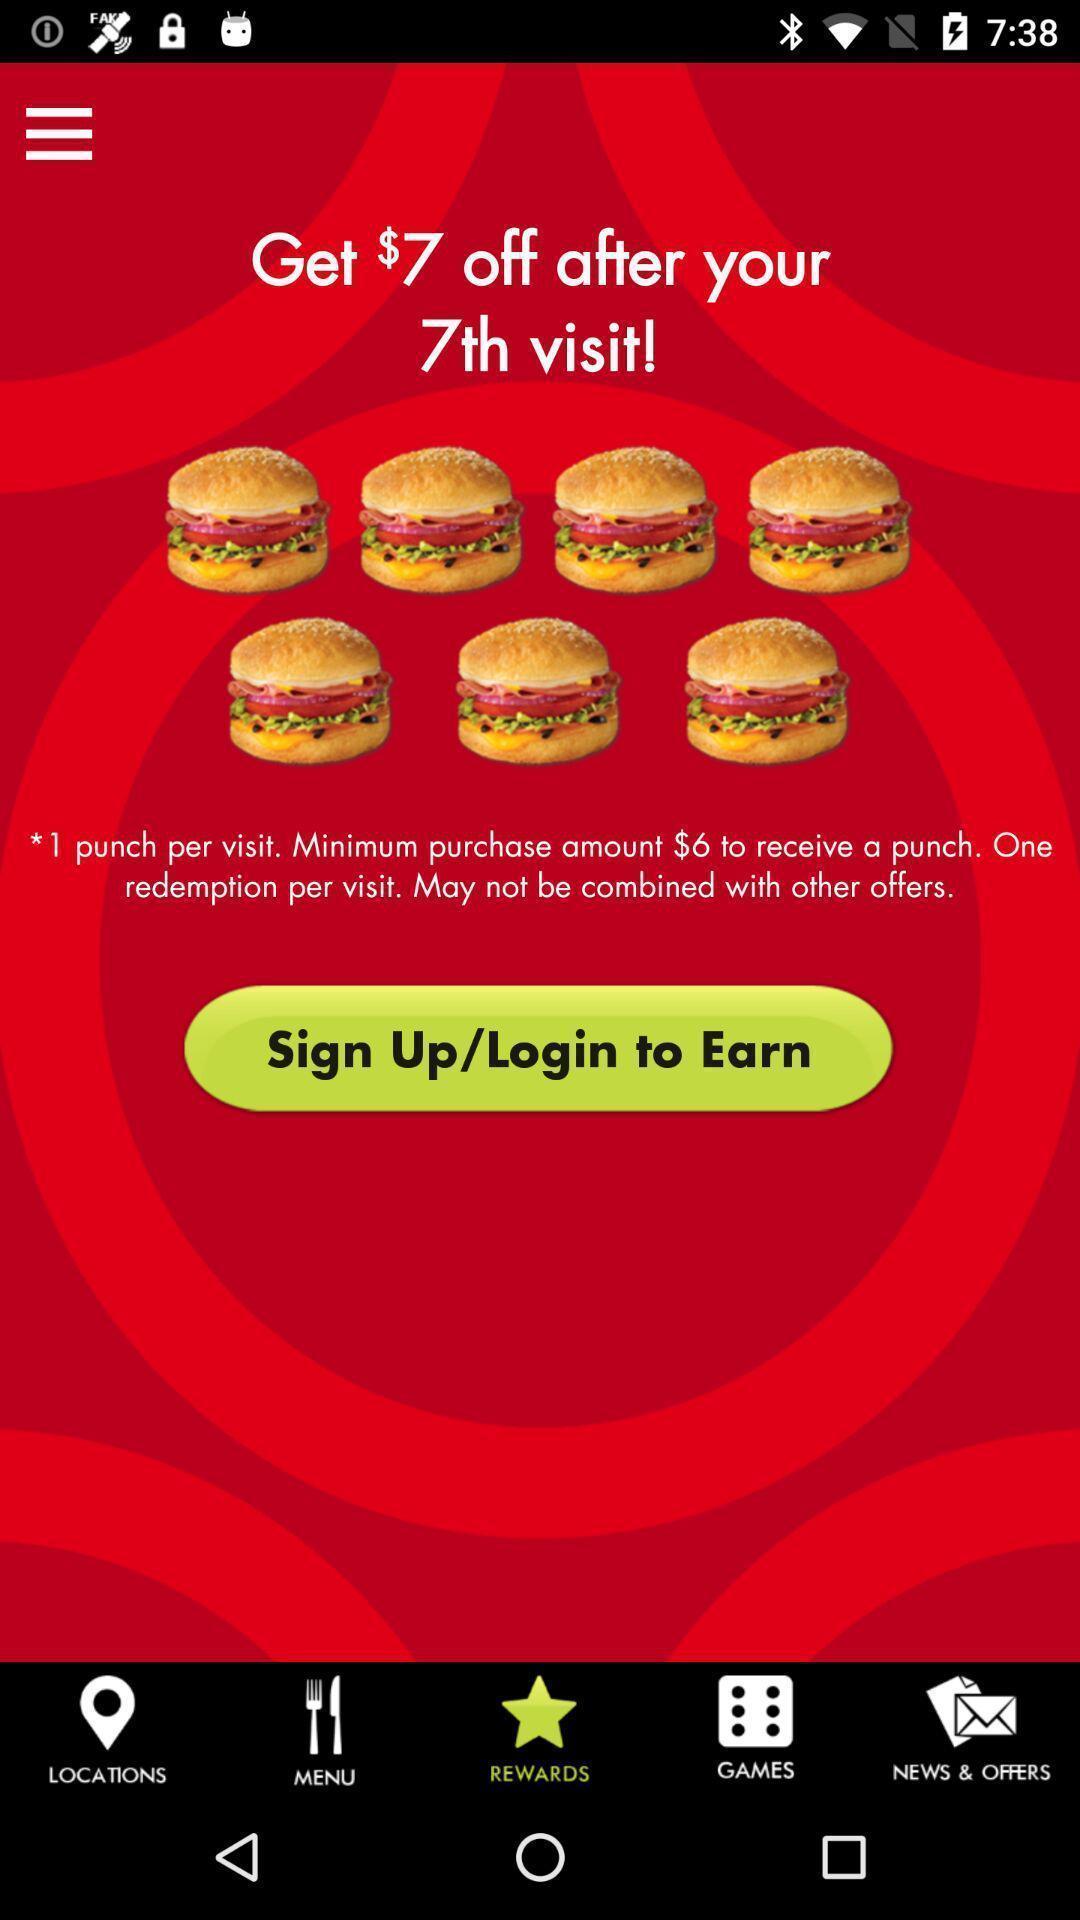What details can you identify in this image? Sign up page. 